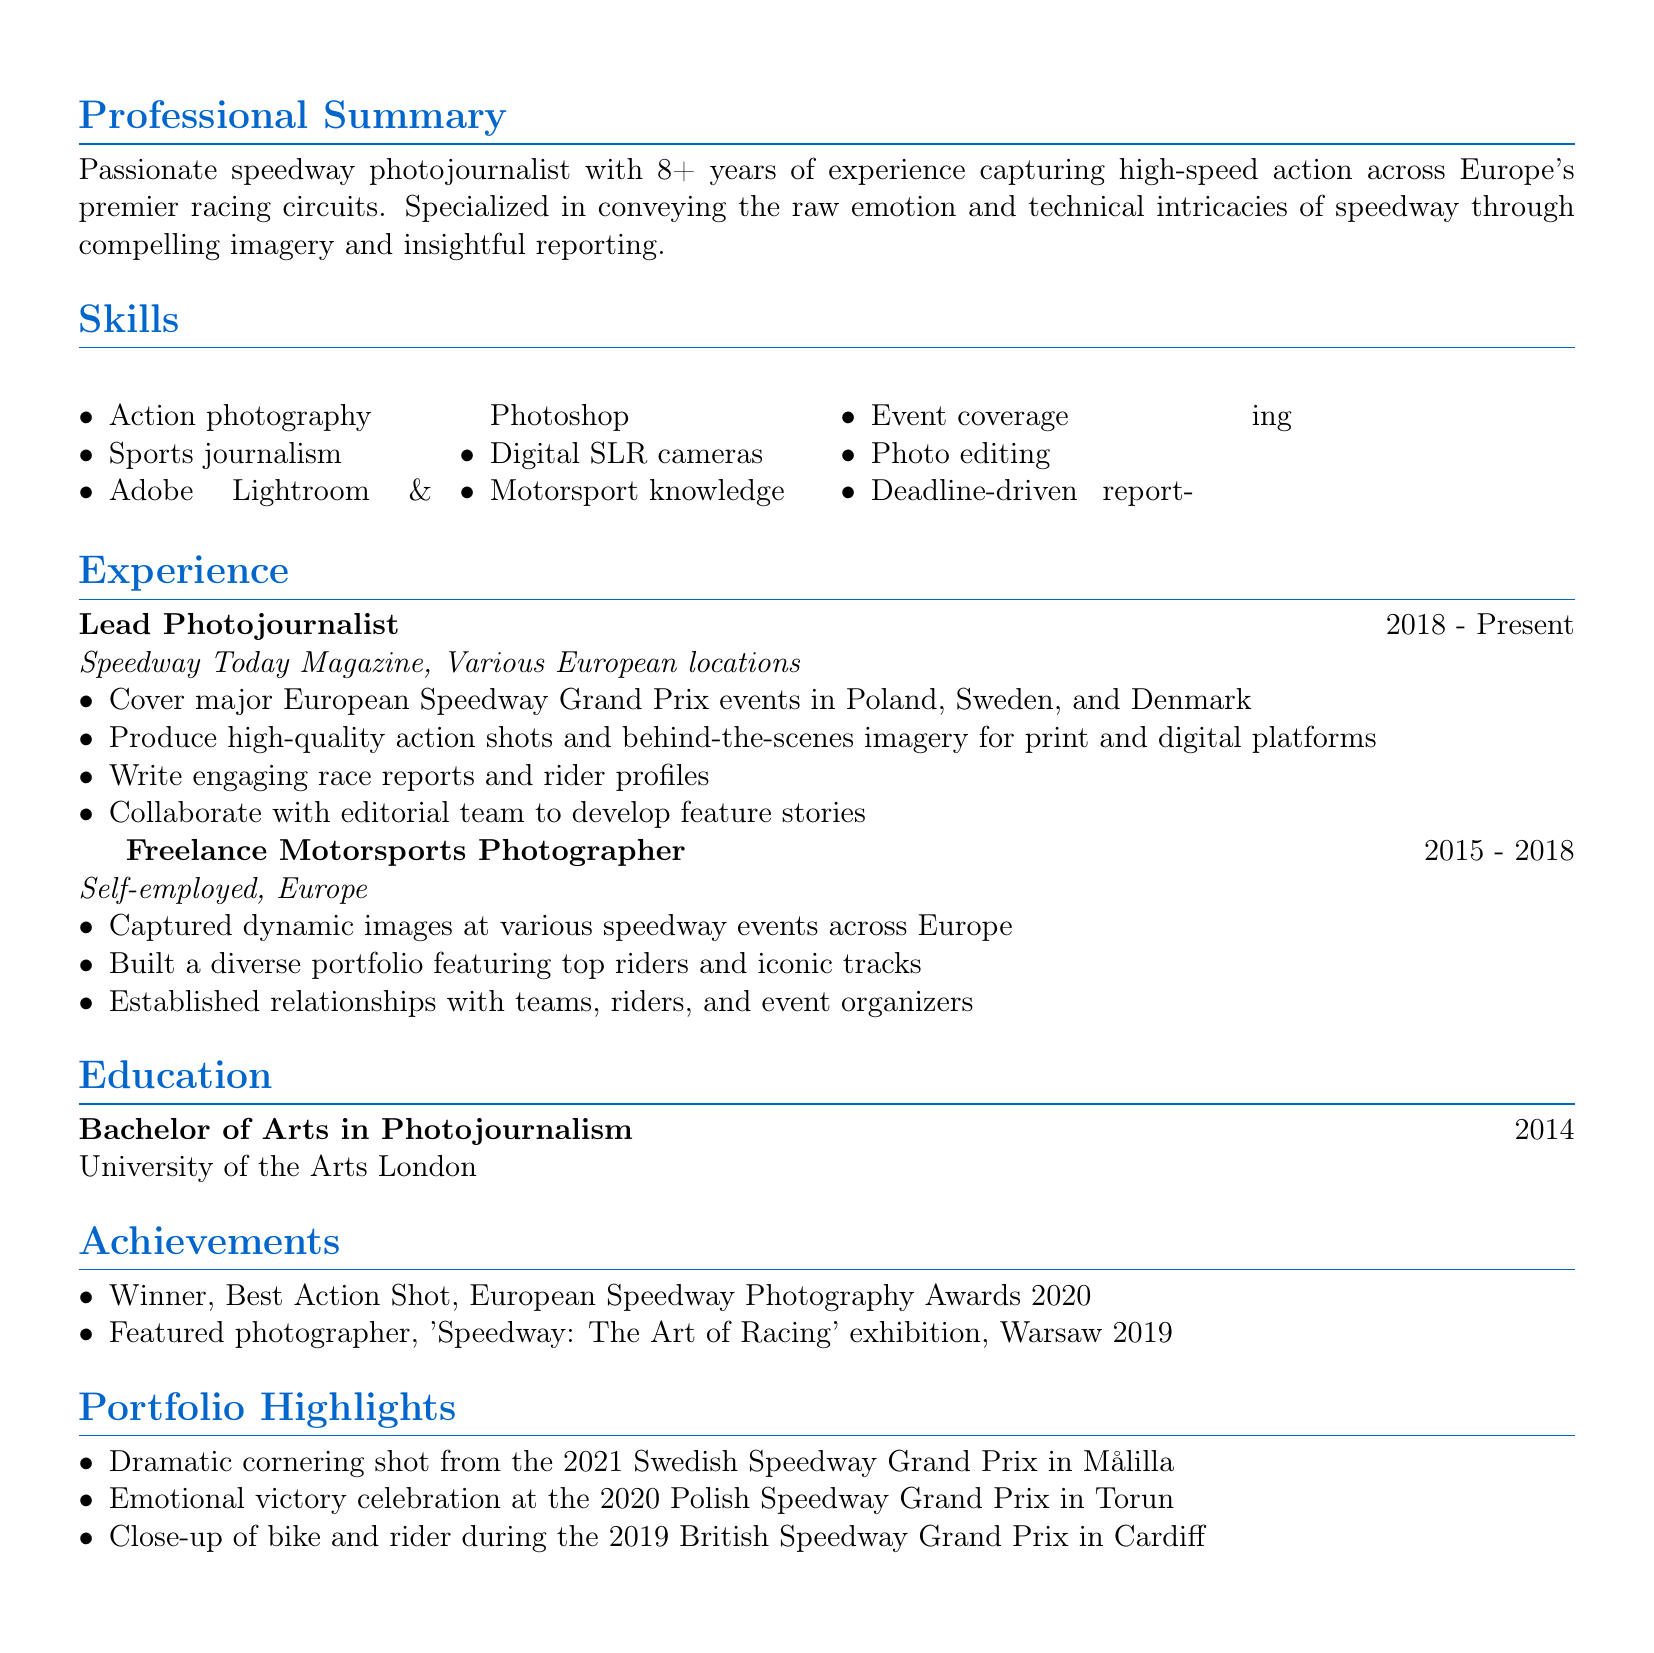What is the name of the photojournalist? The name of the photojournalist is listed in the personal info section of the document.
Answer: Alex Racer What is Alex Racer's location? Alex Racer's location is mentioned in the personal info section of the document.
Answer: London, UK How many years of experience does Alex have? The professional summary states the number of years of experience the photojournalist has.
Answer: 8+ What is the highest award Alex has won? The achievements section mentions the award won by Alex for a specific category.
Answer: Best Action Shot Which institution did Alex graduate from? The education section provides the name of the institution where Alex obtained a degree.
Answer: University of the Arts London In which year did Alex complete their degree? The education section specifies the year Alex graduated.
Answer: 2014 What role did Alex hold from 2018 to present? The experience section lists Alex's title during this time frame.
Answer: Lead Photojournalist What types of photography skills does Alex possess? The skills section lists various skills related to Alex's profession.
Answer: Action photography Which racing events has Alex covered? The experience section details the specific events covered by Alex.
Answer: European Speedway Grand Prix events 